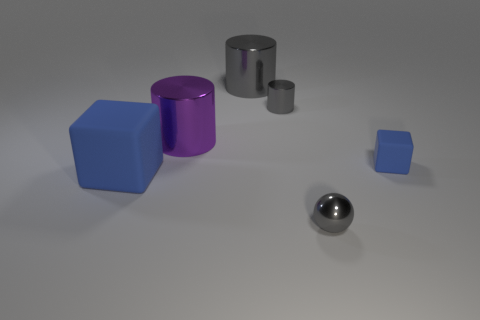How many blue blocks must be subtracted to get 1 blue blocks? 1 Subtract all large cylinders. How many cylinders are left? 1 Subtract all gray cylinders. How many cylinders are left? 1 Add 3 cyan metal cubes. How many objects exist? 9 Subtract 2 cylinders. How many cylinders are left? 1 Subtract all purple cubes. Subtract all green balls. How many cubes are left? 2 Subtract all gray blocks. How many purple cylinders are left? 1 Subtract all small gray rubber balls. Subtract all large gray metal cylinders. How many objects are left? 5 Add 2 matte things. How many matte things are left? 4 Add 2 big gray cylinders. How many big gray cylinders exist? 3 